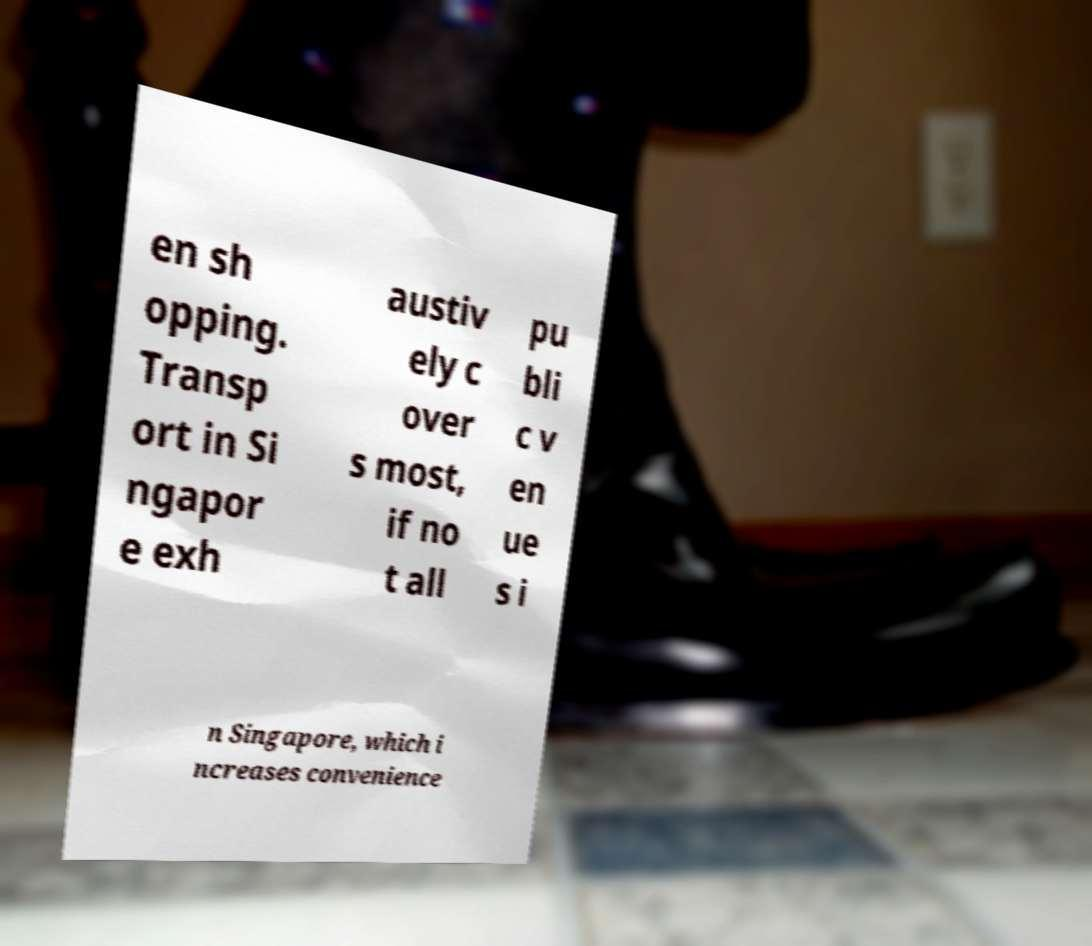Please identify and transcribe the text found in this image. en sh opping. Transp ort in Si ngapor e exh austiv ely c over s most, if no t all pu bli c v en ue s i n Singapore, which i ncreases convenience 